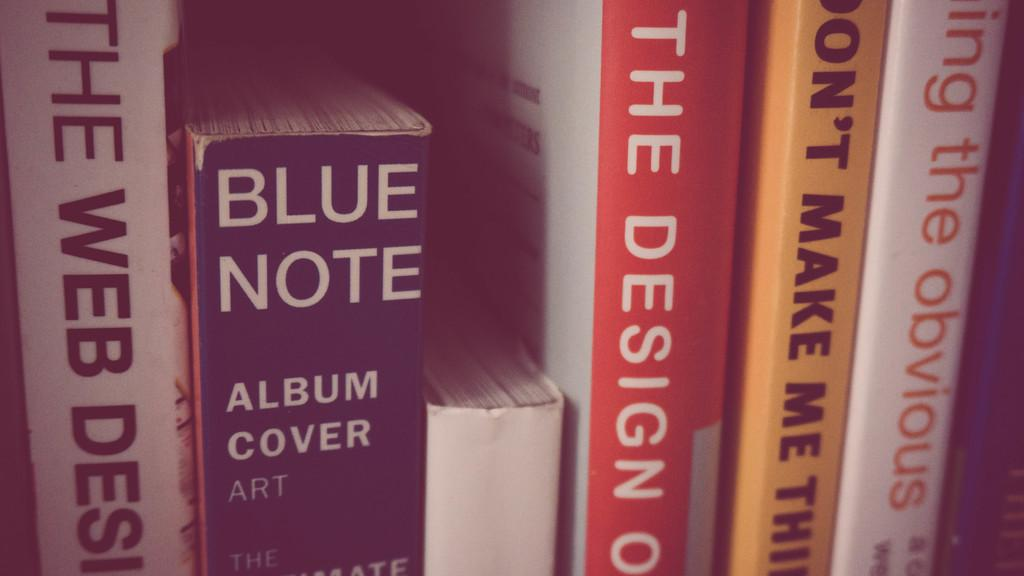<image>
Share a concise interpretation of the image provided. Several books sit on a shelf and one of those books is BLUE NOTE Album Cover Art. 